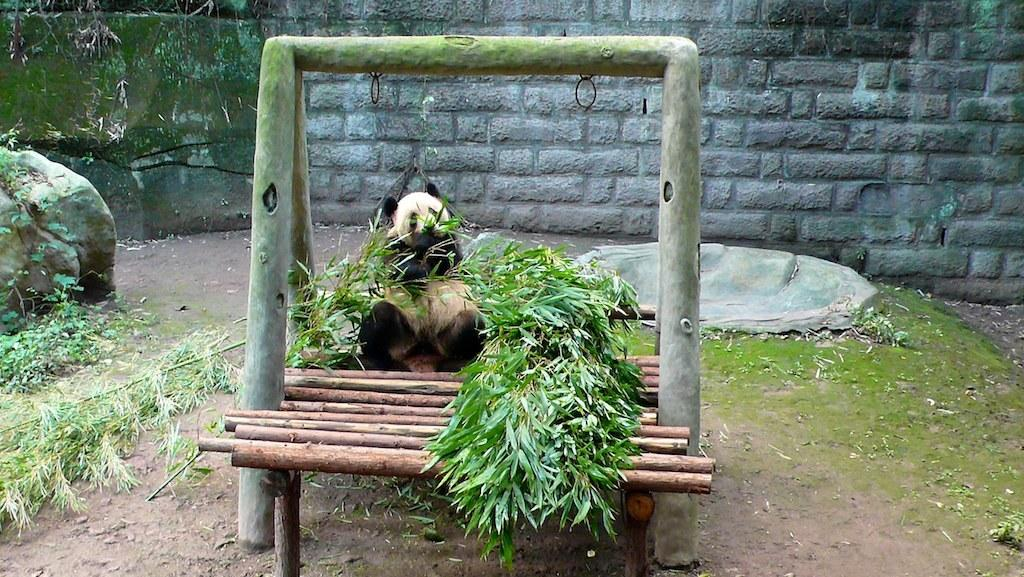What animal is the main subject of the image? There is a panda in the image. Where is the panda sitting? The panda is sitting on a wooden platform. What can be seen in the image besides the panda? There is a stand, handles, leaves, stems, algae, rocks, and a wall in the background of the image. What part of the panda's body is performing arithmetic calculations in the image? There is no part of the panda's body performing arithmetic calculations in the image, as pandas do not have the ability to perform such tasks. How is the panda contributing to waste management in the image? There is no indication in the image that the panda is involved in waste management, as the image focuses on the panda sitting on a wooden platform and the surrounding objects and elements. 